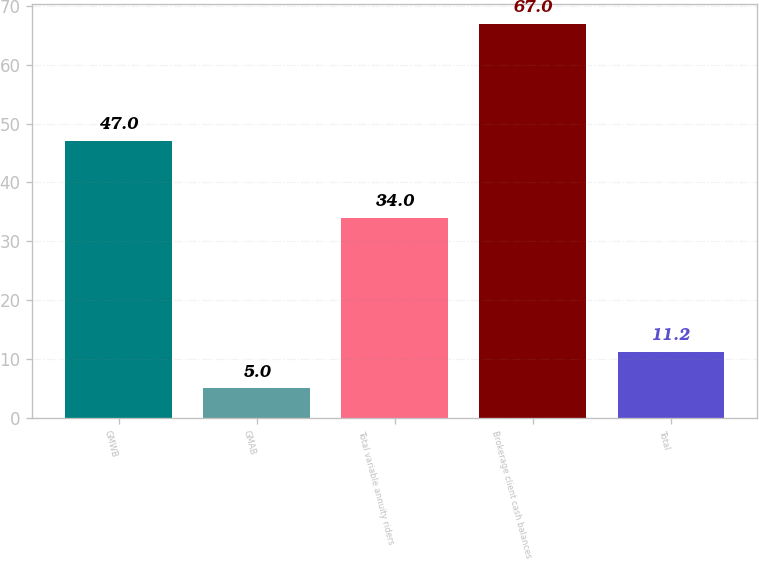Convert chart to OTSL. <chart><loc_0><loc_0><loc_500><loc_500><bar_chart><fcel>GMWB<fcel>GMAB<fcel>Total variable annuity riders<fcel>Brokerage client cash balances<fcel>Total<nl><fcel>47<fcel>5<fcel>34<fcel>67<fcel>11.2<nl></chart> 